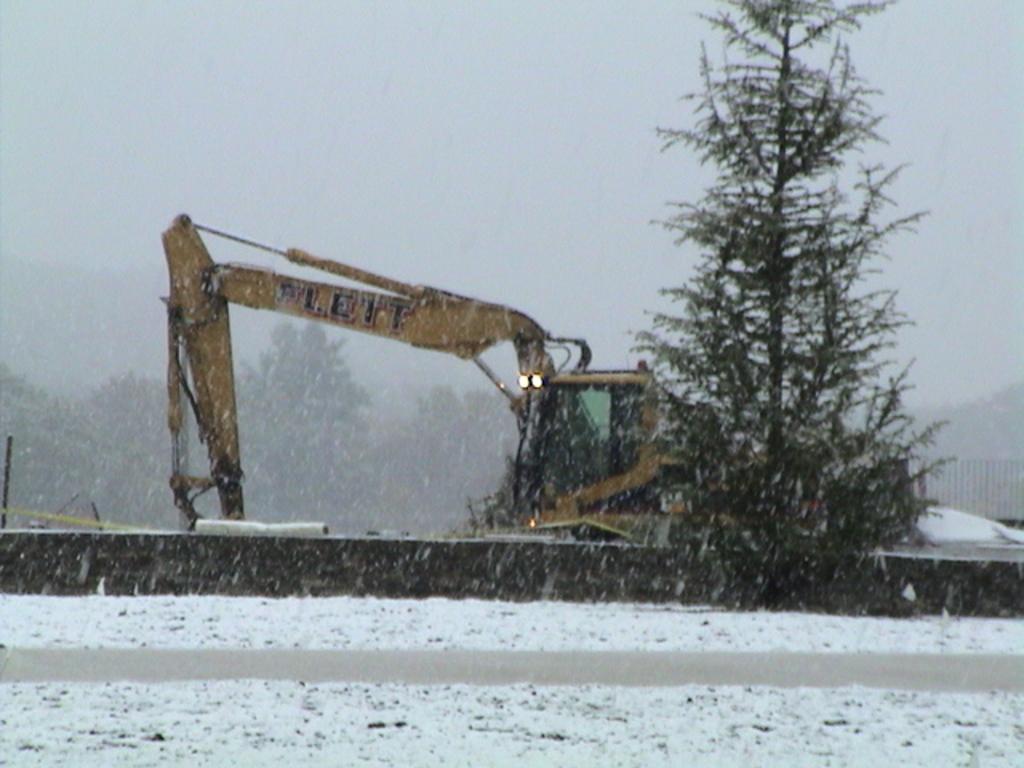Describe this image in one or two sentences. In this image I can see the snowfall. In the middle of the image there is a bulldozer. On the ground, I can see the snow. In the background there are many trees. At the top of the image I can see the sky. 